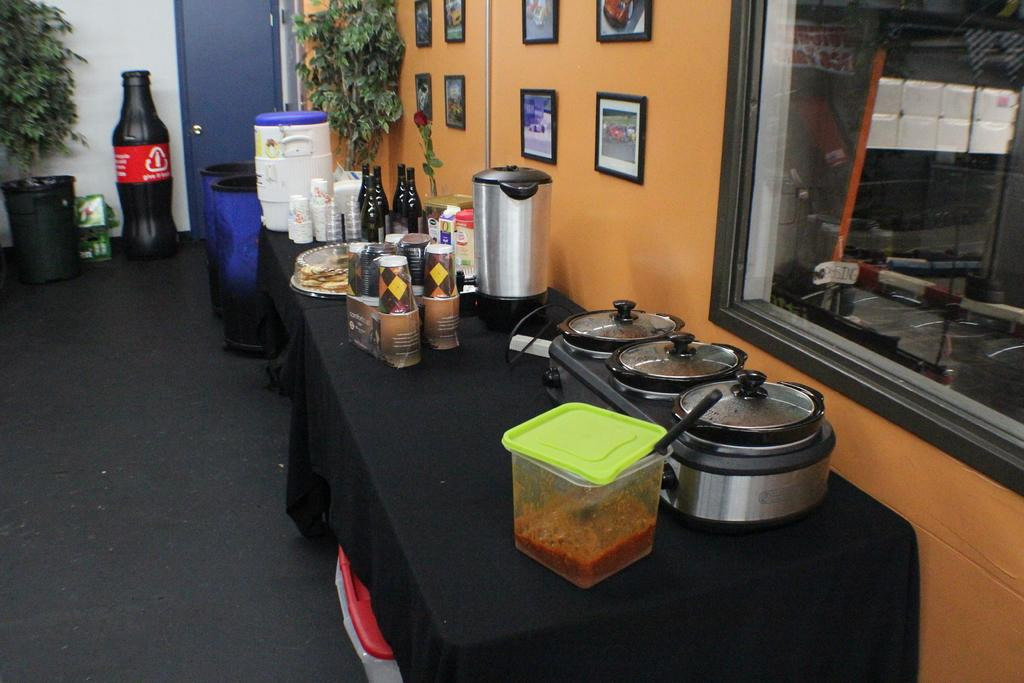<image>
Give a short and clear explanation of the subsequent image. A recycle bin next to the door is shaped like a Coke bottle and tells us to give it back. 